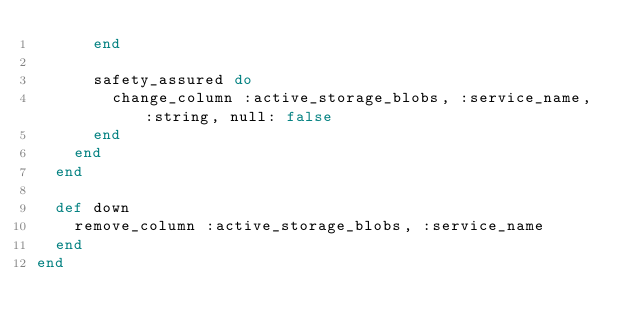Convert code to text. <code><loc_0><loc_0><loc_500><loc_500><_Ruby_>      end

      safety_assured do
        change_column :active_storage_blobs, :service_name, :string, null: false
      end
    end
  end

  def down
    remove_column :active_storage_blobs, :service_name
  end
end
</code> 